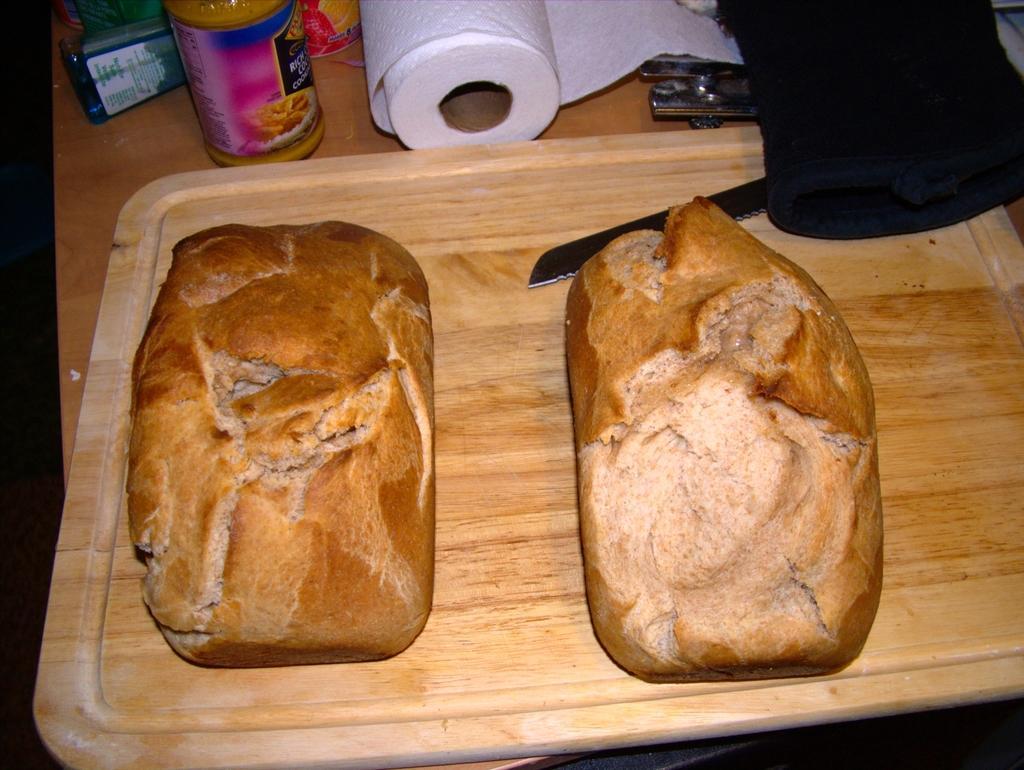Could you give a brief overview of what you see in this image? In this image to the bottom there is a table, and on the table there is one tray. In that tray there are some buns and knife, tissue roll, bottles and some objects. 